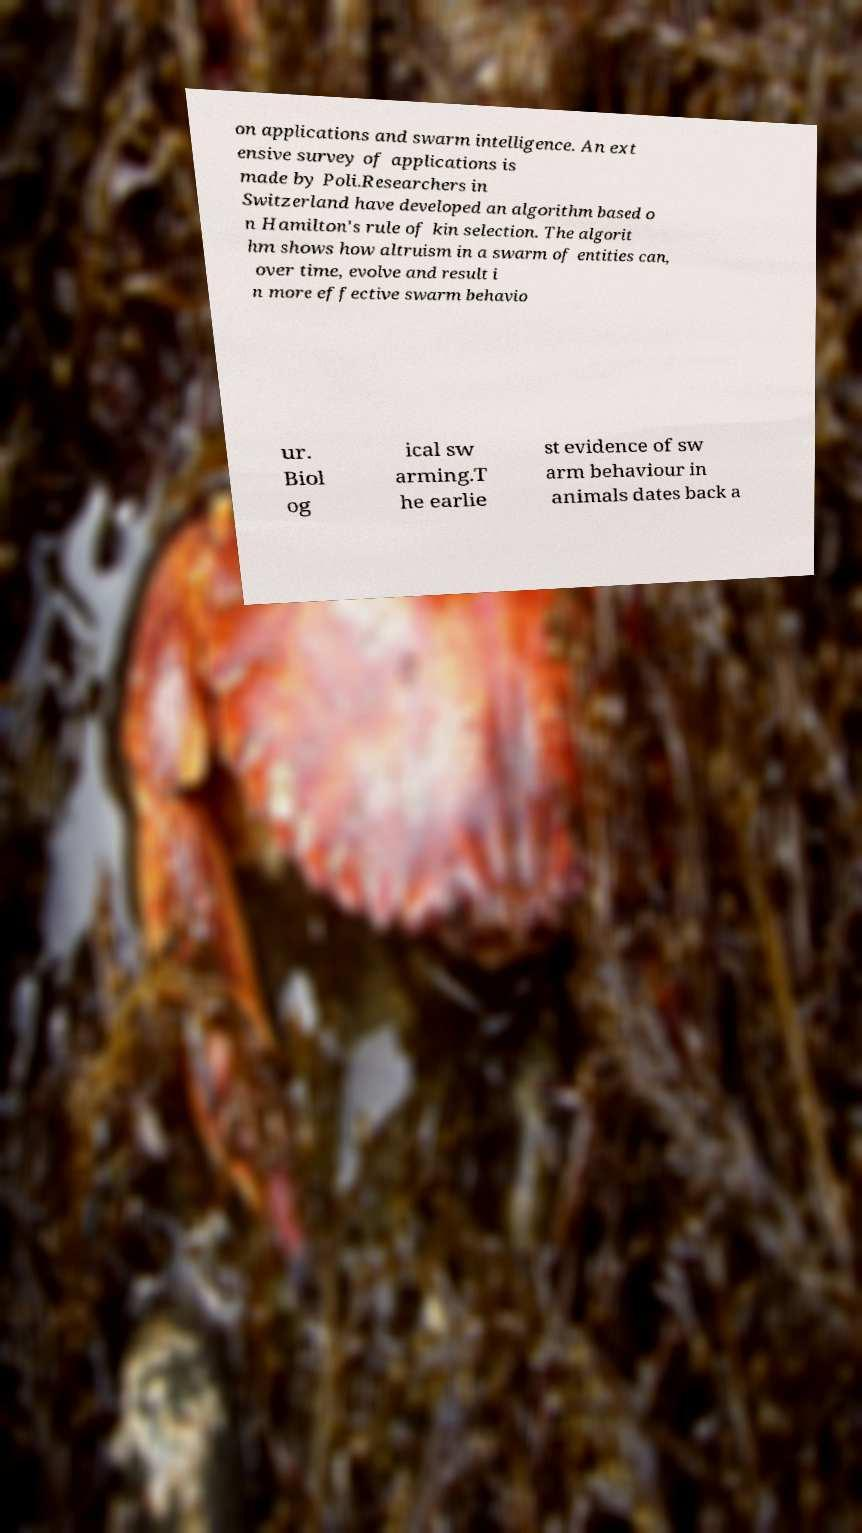I need the written content from this picture converted into text. Can you do that? on applications and swarm intelligence. An ext ensive survey of applications is made by Poli.Researchers in Switzerland have developed an algorithm based o n Hamilton's rule of kin selection. The algorit hm shows how altruism in a swarm of entities can, over time, evolve and result i n more effective swarm behavio ur. Biol og ical sw arming.T he earlie st evidence of sw arm behaviour in animals dates back a 